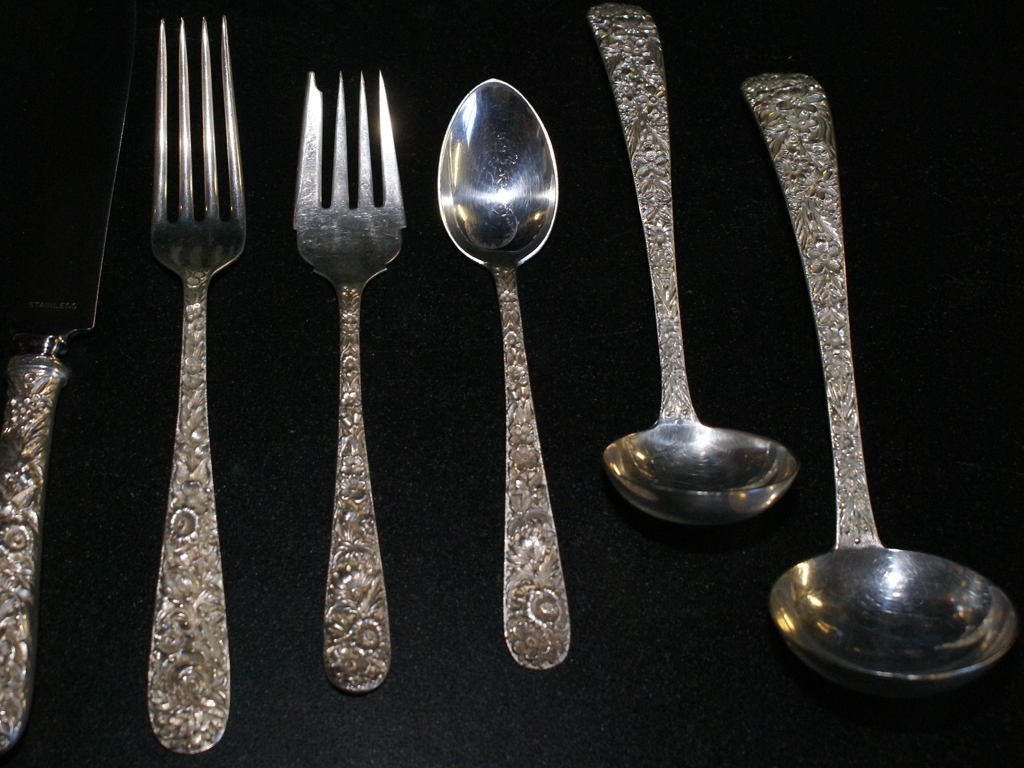Does the image give any clue to the age of these utensils? Although the exact age isn't discernible from the image alone, the ornate pattern and the maintained condition suggest that these utensils could be either well-preserved antiques or modern reproductions inspired by vintage designs. 